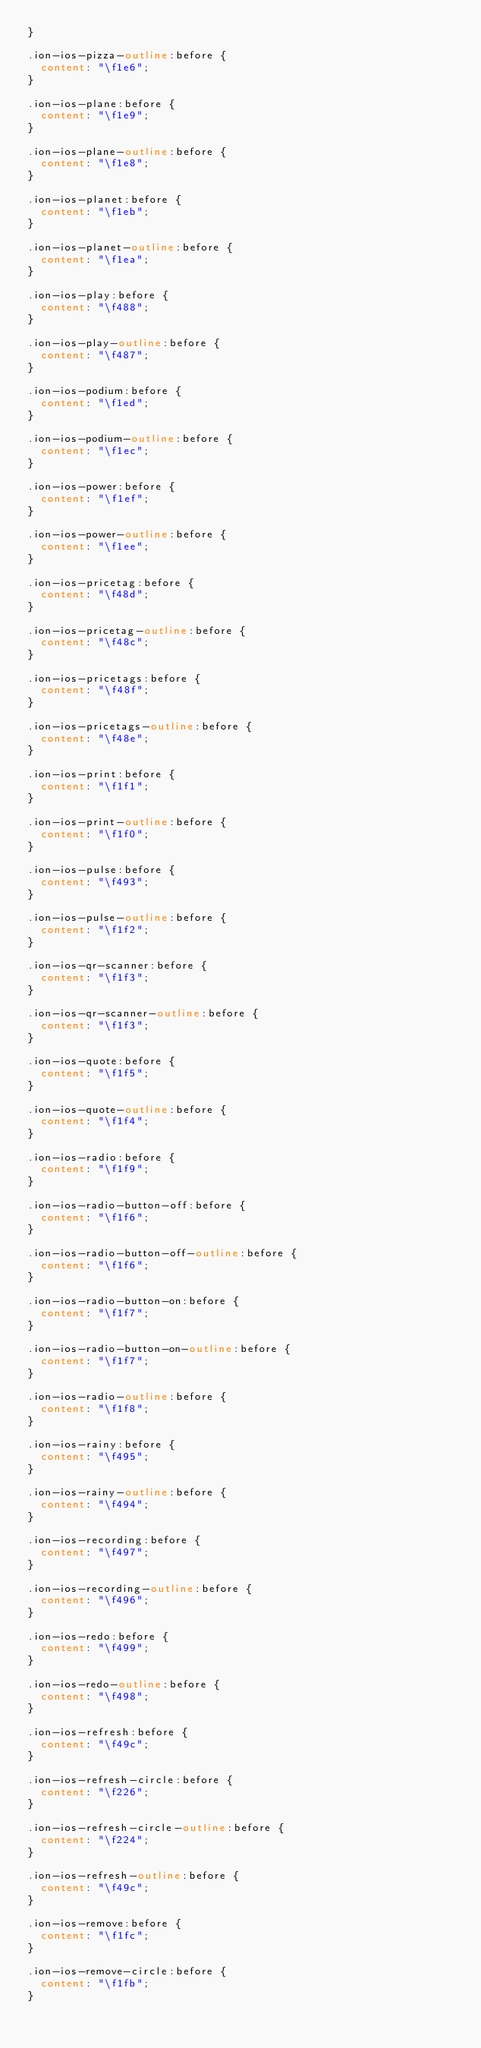<code> <loc_0><loc_0><loc_500><loc_500><_CSS_>}

.ion-ios-pizza-outline:before {
  content: "\f1e6";
}

.ion-ios-plane:before {
  content: "\f1e9";
}

.ion-ios-plane-outline:before {
  content: "\f1e8";
}

.ion-ios-planet:before {
  content: "\f1eb";
}

.ion-ios-planet-outline:before {
  content: "\f1ea";
}

.ion-ios-play:before {
  content: "\f488";
}

.ion-ios-play-outline:before {
  content: "\f487";
}

.ion-ios-podium:before {
  content: "\f1ed";
}

.ion-ios-podium-outline:before {
  content: "\f1ec";
}

.ion-ios-power:before {
  content: "\f1ef";
}

.ion-ios-power-outline:before {
  content: "\f1ee";
}

.ion-ios-pricetag:before {
  content: "\f48d";
}

.ion-ios-pricetag-outline:before {
  content: "\f48c";
}

.ion-ios-pricetags:before {
  content: "\f48f";
}

.ion-ios-pricetags-outline:before {
  content: "\f48e";
}

.ion-ios-print:before {
  content: "\f1f1";
}

.ion-ios-print-outline:before {
  content: "\f1f0";
}

.ion-ios-pulse:before {
  content: "\f493";
}

.ion-ios-pulse-outline:before {
  content: "\f1f2";
}

.ion-ios-qr-scanner:before {
  content: "\f1f3";
}

.ion-ios-qr-scanner-outline:before {
  content: "\f1f3";
}

.ion-ios-quote:before {
  content: "\f1f5";
}

.ion-ios-quote-outline:before {
  content: "\f1f4";
}

.ion-ios-radio:before {
  content: "\f1f9";
}

.ion-ios-radio-button-off:before {
  content: "\f1f6";
}

.ion-ios-radio-button-off-outline:before {
  content: "\f1f6";
}

.ion-ios-radio-button-on:before {
  content: "\f1f7";
}

.ion-ios-radio-button-on-outline:before {
  content: "\f1f7";
}

.ion-ios-radio-outline:before {
  content: "\f1f8";
}

.ion-ios-rainy:before {
  content: "\f495";
}

.ion-ios-rainy-outline:before {
  content: "\f494";
}

.ion-ios-recording:before {
  content: "\f497";
}

.ion-ios-recording-outline:before {
  content: "\f496";
}

.ion-ios-redo:before {
  content: "\f499";
}

.ion-ios-redo-outline:before {
  content: "\f498";
}

.ion-ios-refresh:before {
  content: "\f49c";
}

.ion-ios-refresh-circle:before {
  content: "\f226";
}

.ion-ios-refresh-circle-outline:before {
  content: "\f224";
}

.ion-ios-refresh-outline:before {
  content: "\f49c";
}

.ion-ios-remove:before {
  content: "\f1fc";
}

.ion-ios-remove-circle:before {
  content: "\f1fb";
}
</code> 